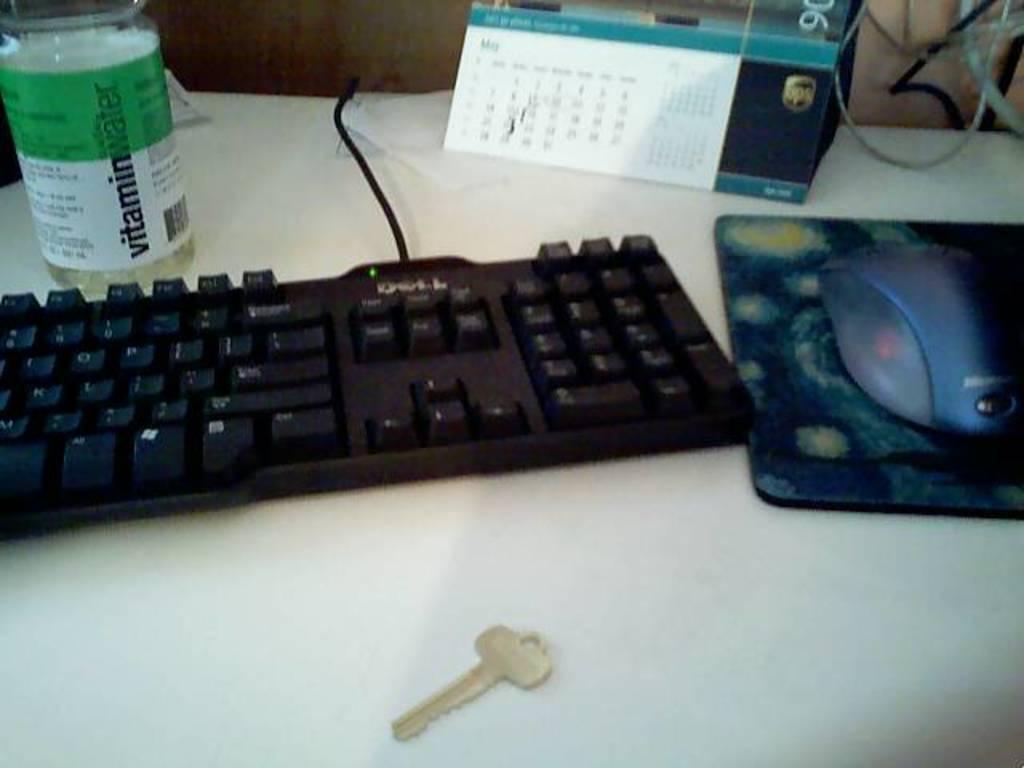Could you give a brief overview of what you see in this image? In this image we can see a bottle, key board, calendar, mouse, mouse pad and key on the white surface. Right top of the image wires are there. 